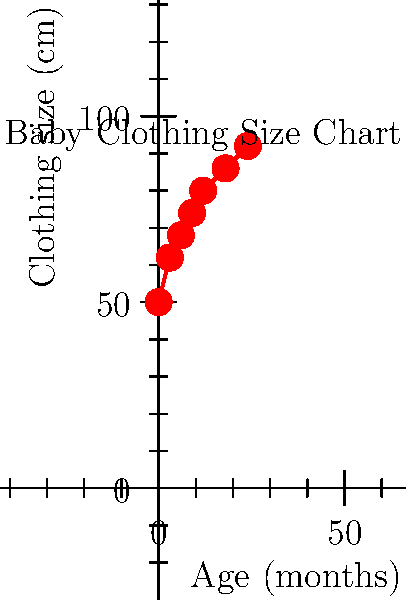Based on the baby clothing size chart shown, if a baby is wearing clothes labeled size 74 cm, what is the estimated age range of the baby? To determine the estimated age range of a baby wearing size 74 cm clothes, let's follow these steps:

1. Locate the 74 cm size on the vertical axis of the chart.
2. Draw an imaginary horizontal line from the 74 cm point to intersect with the graph line.
3. From the intersection point, draw an imaginary vertical line down to the horizontal axis.
4. The point where this vertical line meets the horizontal axis gives us the approximate age in months.

Looking at the chart, we can see that the 74 cm size corresponds to approximately 9 months on the age axis.

However, it's important to note that babies grow at different rates, and clothing sizes can vary slightly between brands. Therefore, it's more accurate to provide an age range rather than a single age.

Considering these factors, we can estimate that a baby wearing size 74 cm clothes is likely to be between 8 and 10 months old.
Answer: 8-10 months 